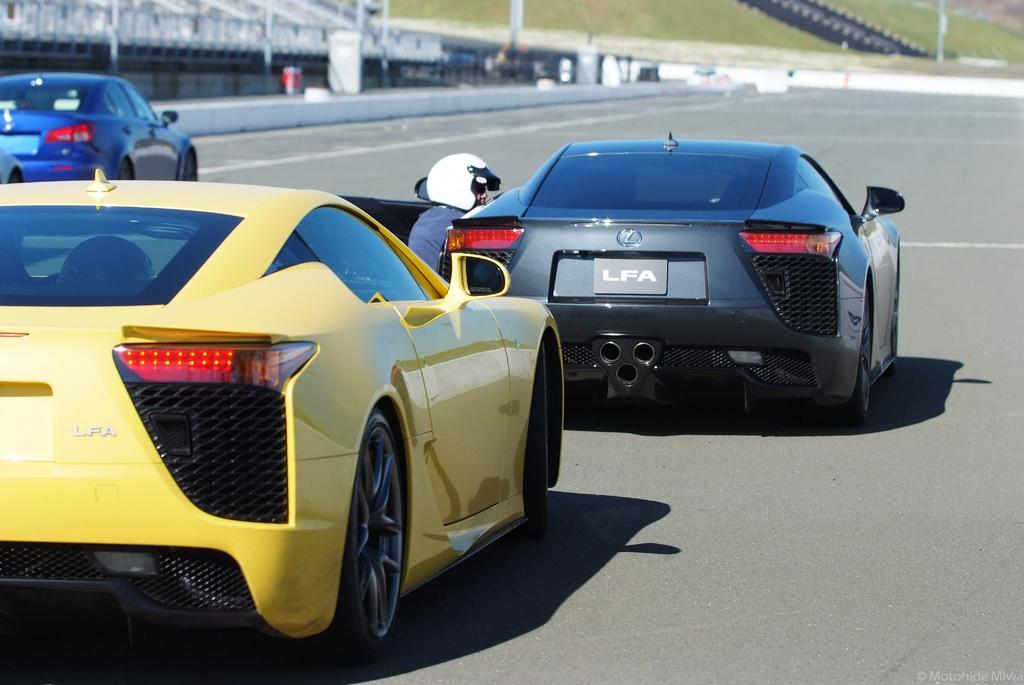What type of vehicles can be seen on the road in the image? There are sports cars on the road in the image. What can be seen on the ground in the background of the image? There is green grass visible on the ground in the background of the image. What type of beast can be seen roaming in the grass in the image? There is no beast present in the image; it only features sports cars on the road and green grass in the background. 